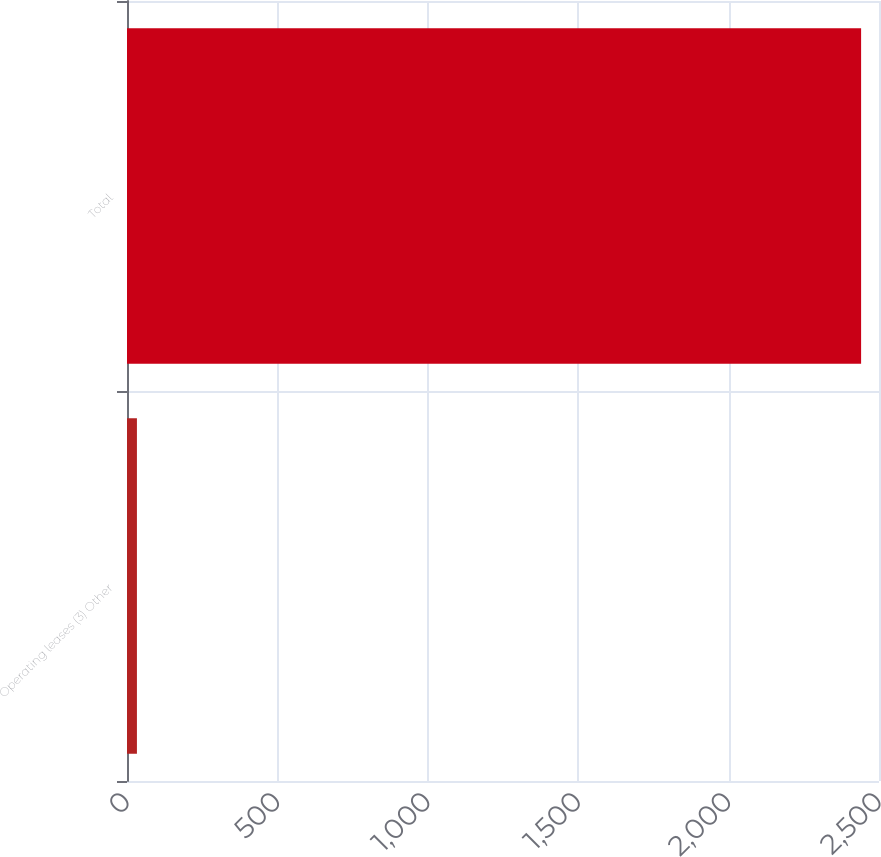Convert chart to OTSL. <chart><loc_0><loc_0><loc_500><loc_500><bar_chart><fcel>Operating leases (3) Other<fcel>Total<nl><fcel>33<fcel>2440.5<nl></chart> 